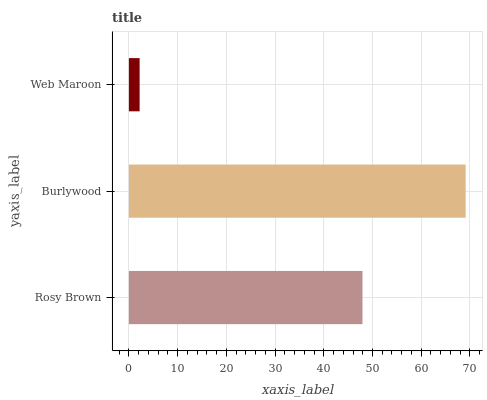Is Web Maroon the minimum?
Answer yes or no. Yes. Is Burlywood the maximum?
Answer yes or no. Yes. Is Burlywood the minimum?
Answer yes or no. No. Is Web Maroon the maximum?
Answer yes or no. No. Is Burlywood greater than Web Maroon?
Answer yes or no. Yes. Is Web Maroon less than Burlywood?
Answer yes or no. Yes. Is Web Maroon greater than Burlywood?
Answer yes or no. No. Is Burlywood less than Web Maroon?
Answer yes or no. No. Is Rosy Brown the high median?
Answer yes or no. Yes. Is Rosy Brown the low median?
Answer yes or no. Yes. Is Web Maroon the high median?
Answer yes or no. No. Is Web Maroon the low median?
Answer yes or no. No. 